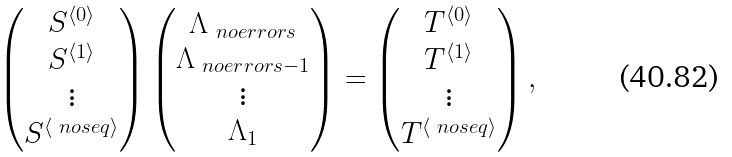<formula> <loc_0><loc_0><loc_500><loc_500>\begin{pmatrix} S ^ { \langle 0 \rangle } \\ S ^ { \langle 1 \rangle } \\ \vdots \\ S ^ { \langle \ n o s e q \rangle } \end{pmatrix} \begin{pmatrix} \Lambda _ { \ n o e r r o r s } \\ \Lambda _ { \ n o e r r o r s - 1 } \\ \vdots \\ \Lambda _ { 1 } \end{pmatrix} = \begin{pmatrix} T ^ { \langle 0 \rangle } \\ T ^ { \langle 1 \rangle } \\ \vdots \\ T ^ { \langle \ n o s e q \rangle } \end{pmatrix} ,</formula> 